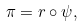Convert formula to latex. <formula><loc_0><loc_0><loc_500><loc_500>\pi = r \circ \psi ,</formula> 